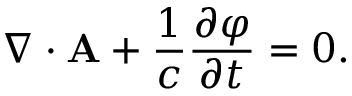<formula> <loc_0><loc_0><loc_500><loc_500>\nabla \cdot { A } + { \frac { 1 } { c } } { \frac { \partial \varphi } { \partial t } } = 0 .</formula> 